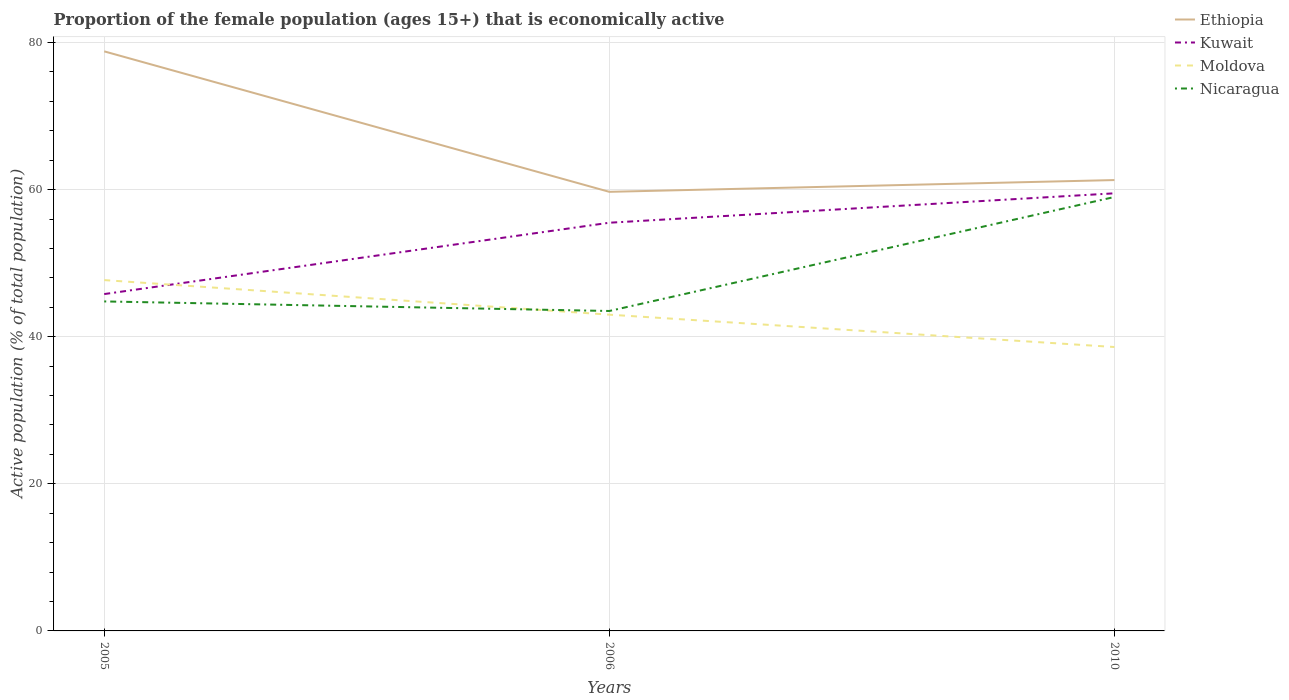How many different coloured lines are there?
Give a very brief answer. 4. Is the number of lines equal to the number of legend labels?
Offer a very short reply. Yes. Across all years, what is the maximum proportion of the female population that is economically active in Ethiopia?
Your answer should be compact. 59.7. Is the proportion of the female population that is economically active in Nicaragua strictly greater than the proportion of the female population that is economically active in Moldova over the years?
Offer a terse response. No. How many lines are there?
Provide a short and direct response. 4. How many years are there in the graph?
Offer a terse response. 3. Are the values on the major ticks of Y-axis written in scientific E-notation?
Offer a very short reply. No. Does the graph contain any zero values?
Offer a very short reply. No. How are the legend labels stacked?
Offer a terse response. Vertical. What is the title of the graph?
Make the answer very short. Proportion of the female population (ages 15+) that is economically active. What is the label or title of the Y-axis?
Offer a very short reply. Active population (% of total population). What is the Active population (% of total population) in Ethiopia in 2005?
Ensure brevity in your answer.  78.8. What is the Active population (% of total population) of Kuwait in 2005?
Your answer should be very brief. 45.8. What is the Active population (% of total population) in Moldova in 2005?
Give a very brief answer. 47.7. What is the Active population (% of total population) in Nicaragua in 2005?
Keep it short and to the point. 44.8. What is the Active population (% of total population) in Ethiopia in 2006?
Your answer should be compact. 59.7. What is the Active population (% of total population) in Kuwait in 2006?
Your response must be concise. 55.5. What is the Active population (% of total population) in Nicaragua in 2006?
Provide a short and direct response. 43.5. What is the Active population (% of total population) of Ethiopia in 2010?
Your response must be concise. 61.3. What is the Active population (% of total population) in Kuwait in 2010?
Your response must be concise. 59.5. What is the Active population (% of total population) in Moldova in 2010?
Offer a terse response. 38.6. What is the Active population (% of total population) in Nicaragua in 2010?
Offer a very short reply. 59. Across all years, what is the maximum Active population (% of total population) in Ethiopia?
Give a very brief answer. 78.8. Across all years, what is the maximum Active population (% of total population) of Kuwait?
Offer a terse response. 59.5. Across all years, what is the maximum Active population (% of total population) in Moldova?
Your answer should be very brief. 47.7. Across all years, what is the minimum Active population (% of total population) in Ethiopia?
Provide a succinct answer. 59.7. Across all years, what is the minimum Active population (% of total population) in Kuwait?
Keep it short and to the point. 45.8. Across all years, what is the minimum Active population (% of total population) of Moldova?
Your answer should be very brief. 38.6. Across all years, what is the minimum Active population (% of total population) in Nicaragua?
Make the answer very short. 43.5. What is the total Active population (% of total population) of Ethiopia in the graph?
Provide a short and direct response. 199.8. What is the total Active population (% of total population) in Kuwait in the graph?
Your answer should be compact. 160.8. What is the total Active population (% of total population) in Moldova in the graph?
Your answer should be very brief. 129.3. What is the total Active population (% of total population) of Nicaragua in the graph?
Offer a very short reply. 147.3. What is the difference between the Active population (% of total population) of Ethiopia in 2005 and that in 2006?
Offer a terse response. 19.1. What is the difference between the Active population (% of total population) of Ethiopia in 2005 and that in 2010?
Provide a succinct answer. 17.5. What is the difference between the Active population (% of total population) in Kuwait in 2005 and that in 2010?
Ensure brevity in your answer.  -13.7. What is the difference between the Active population (% of total population) of Nicaragua in 2005 and that in 2010?
Provide a short and direct response. -14.2. What is the difference between the Active population (% of total population) of Moldova in 2006 and that in 2010?
Offer a very short reply. 4.4. What is the difference between the Active population (% of total population) of Nicaragua in 2006 and that in 2010?
Offer a very short reply. -15.5. What is the difference between the Active population (% of total population) in Ethiopia in 2005 and the Active population (% of total population) in Kuwait in 2006?
Offer a terse response. 23.3. What is the difference between the Active population (% of total population) in Ethiopia in 2005 and the Active population (% of total population) in Moldova in 2006?
Offer a terse response. 35.8. What is the difference between the Active population (% of total population) in Ethiopia in 2005 and the Active population (% of total population) in Nicaragua in 2006?
Your answer should be very brief. 35.3. What is the difference between the Active population (% of total population) of Moldova in 2005 and the Active population (% of total population) of Nicaragua in 2006?
Offer a very short reply. 4.2. What is the difference between the Active population (% of total population) of Ethiopia in 2005 and the Active population (% of total population) of Kuwait in 2010?
Your answer should be compact. 19.3. What is the difference between the Active population (% of total population) of Ethiopia in 2005 and the Active population (% of total population) of Moldova in 2010?
Make the answer very short. 40.2. What is the difference between the Active population (% of total population) of Ethiopia in 2005 and the Active population (% of total population) of Nicaragua in 2010?
Offer a very short reply. 19.8. What is the difference between the Active population (% of total population) in Kuwait in 2005 and the Active population (% of total population) in Moldova in 2010?
Your response must be concise. 7.2. What is the difference between the Active population (% of total population) of Kuwait in 2005 and the Active population (% of total population) of Nicaragua in 2010?
Your answer should be very brief. -13.2. What is the difference between the Active population (% of total population) of Moldova in 2005 and the Active population (% of total population) of Nicaragua in 2010?
Your answer should be very brief. -11.3. What is the difference between the Active population (% of total population) in Ethiopia in 2006 and the Active population (% of total population) in Kuwait in 2010?
Ensure brevity in your answer.  0.2. What is the difference between the Active population (% of total population) of Ethiopia in 2006 and the Active population (% of total population) of Moldova in 2010?
Ensure brevity in your answer.  21.1. What is the difference between the Active population (% of total population) in Moldova in 2006 and the Active population (% of total population) in Nicaragua in 2010?
Your response must be concise. -16. What is the average Active population (% of total population) of Ethiopia per year?
Offer a very short reply. 66.6. What is the average Active population (% of total population) in Kuwait per year?
Offer a terse response. 53.6. What is the average Active population (% of total population) in Moldova per year?
Your answer should be very brief. 43.1. What is the average Active population (% of total population) of Nicaragua per year?
Keep it short and to the point. 49.1. In the year 2005, what is the difference between the Active population (% of total population) in Ethiopia and Active population (% of total population) in Kuwait?
Your response must be concise. 33. In the year 2005, what is the difference between the Active population (% of total population) in Ethiopia and Active population (% of total population) in Moldova?
Ensure brevity in your answer.  31.1. In the year 2005, what is the difference between the Active population (% of total population) of Ethiopia and Active population (% of total population) of Nicaragua?
Give a very brief answer. 34. In the year 2005, what is the difference between the Active population (% of total population) in Kuwait and Active population (% of total population) in Moldova?
Offer a terse response. -1.9. In the year 2005, what is the difference between the Active population (% of total population) in Kuwait and Active population (% of total population) in Nicaragua?
Provide a succinct answer. 1. In the year 2005, what is the difference between the Active population (% of total population) in Moldova and Active population (% of total population) in Nicaragua?
Make the answer very short. 2.9. In the year 2006, what is the difference between the Active population (% of total population) of Ethiopia and Active population (% of total population) of Kuwait?
Offer a very short reply. 4.2. In the year 2006, what is the difference between the Active population (% of total population) in Kuwait and Active population (% of total population) in Moldova?
Your answer should be very brief. 12.5. In the year 2006, what is the difference between the Active population (% of total population) of Moldova and Active population (% of total population) of Nicaragua?
Your response must be concise. -0.5. In the year 2010, what is the difference between the Active population (% of total population) of Ethiopia and Active population (% of total population) of Kuwait?
Keep it short and to the point. 1.8. In the year 2010, what is the difference between the Active population (% of total population) in Ethiopia and Active population (% of total population) in Moldova?
Give a very brief answer. 22.7. In the year 2010, what is the difference between the Active population (% of total population) in Ethiopia and Active population (% of total population) in Nicaragua?
Provide a succinct answer. 2.3. In the year 2010, what is the difference between the Active population (% of total population) in Kuwait and Active population (% of total population) in Moldova?
Your response must be concise. 20.9. In the year 2010, what is the difference between the Active population (% of total population) in Moldova and Active population (% of total population) in Nicaragua?
Make the answer very short. -20.4. What is the ratio of the Active population (% of total population) of Ethiopia in 2005 to that in 2006?
Keep it short and to the point. 1.32. What is the ratio of the Active population (% of total population) in Kuwait in 2005 to that in 2006?
Ensure brevity in your answer.  0.83. What is the ratio of the Active population (% of total population) in Moldova in 2005 to that in 2006?
Offer a very short reply. 1.11. What is the ratio of the Active population (% of total population) in Nicaragua in 2005 to that in 2006?
Keep it short and to the point. 1.03. What is the ratio of the Active population (% of total population) of Ethiopia in 2005 to that in 2010?
Your answer should be compact. 1.29. What is the ratio of the Active population (% of total population) of Kuwait in 2005 to that in 2010?
Ensure brevity in your answer.  0.77. What is the ratio of the Active population (% of total population) in Moldova in 2005 to that in 2010?
Keep it short and to the point. 1.24. What is the ratio of the Active population (% of total population) of Nicaragua in 2005 to that in 2010?
Your answer should be compact. 0.76. What is the ratio of the Active population (% of total population) in Ethiopia in 2006 to that in 2010?
Provide a succinct answer. 0.97. What is the ratio of the Active population (% of total population) in Kuwait in 2006 to that in 2010?
Give a very brief answer. 0.93. What is the ratio of the Active population (% of total population) of Moldova in 2006 to that in 2010?
Your response must be concise. 1.11. What is the ratio of the Active population (% of total population) in Nicaragua in 2006 to that in 2010?
Give a very brief answer. 0.74. What is the difference between the highest and the second highest Active population (% of total population) of Moldova?
Keep it short and to the point. 4.7. What is the difference between the highest and the second highest Active population (% of total population) in Nicaragua?
Your response must be concise. 14.2. What is the difference between the highest and the lowest Active population (% of total population) in Ethiopia?
Your response must be concise. 19.1. What is the difference between the highest and the lowest Active population (% of total population) of Moldova?
Provide a short and direct response. 9.1. 